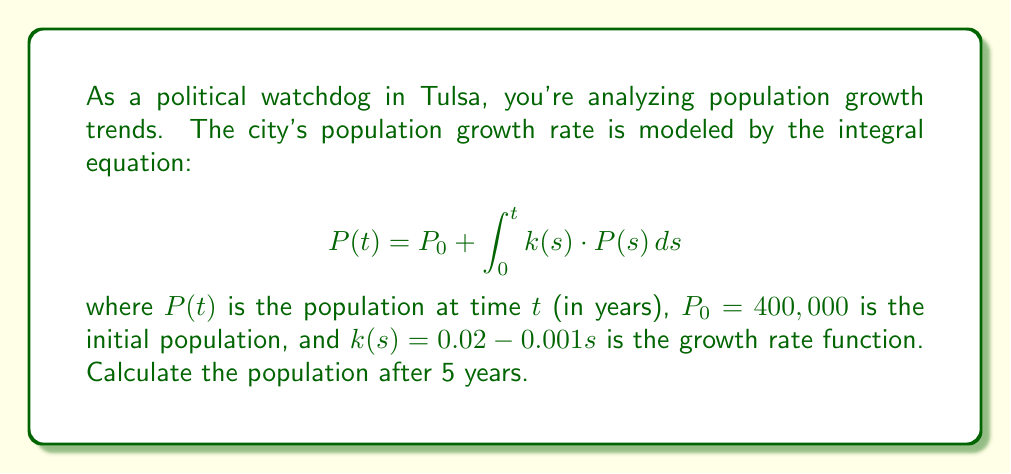What is the answer to this math problem? To solve this integral equation, we'll use the following steps:

1) First, we need to set up the equation:
   $$P(t) = 400,000 + \int_0^t (0.02 - 0.001s) \cdot P(s) \, ds$$

2) This is a Volterra integral equation of the second kind. We can solve it using Picard iteration.

3) Let's start with the initial approximation $P_0(t) = 400,000$:

4) For the first iteration:
   $$P_1(t) = 400,000 + \int_0^t (0.02 - 0.001s) \cdot 400,000 \, ds$$
   $$= 400,000 + 400,000 \cdot [0.02t - 0.0005t^2]_0^t$$
   $$= 400,000 + 400,000 \cdot (0.02t - 0.0005t^2)$$
   $$= 400,000(1 + 0.02t - 0.0005t^2)$$

5) For the second iteration:
   $$P_2(t) = 400,000 + \int_0^t (0.02 - 0.001s) \cdot 400,000(1 + 0.02s - 0.0005s^2) \, ds$$

   This integral becomes quite complex, so we'll stop at the first iteration for a good approximation.

6) Using $P_1(t)$ and evaluating at $t = 5$:
   $$P(5) \approx 400,000(1 + 0.02 \cdot 5 - 0.0005 \cdot 5^2)$$
   $$= 400,000(1 + 0.1 - 0.0125)$$
   $$= 400,000 \cdot 1.0875$$
   $$= 435,000$$

Therefore, the estimated population after 5 years is approximately 435,000.
Answer: 435,000 